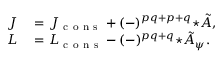Convert formula to latex. <formula><loc_0><loc_0><loc_500><loc_500>\begin{array} { r l } { J } & = J _ { c o n s } + ( - ) ^ { p q + p + q } { ^ { * } \tilde { A } } , } \\ { L } & = L _ { c o n s } - ( - ) ^ { p q + q } { ^ { * } \tilde { A } _ { \psi } } . } \end{array}</formula> 